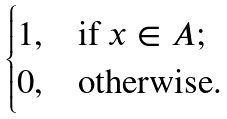Convert formula to latex. <formula><loc_0><loc_0><loc_500><loc_500>\begin{cases} 1 , & \text {if $x \in A$;} \\ 0 , & \text {otherwise.} \end{cases}</formula> 